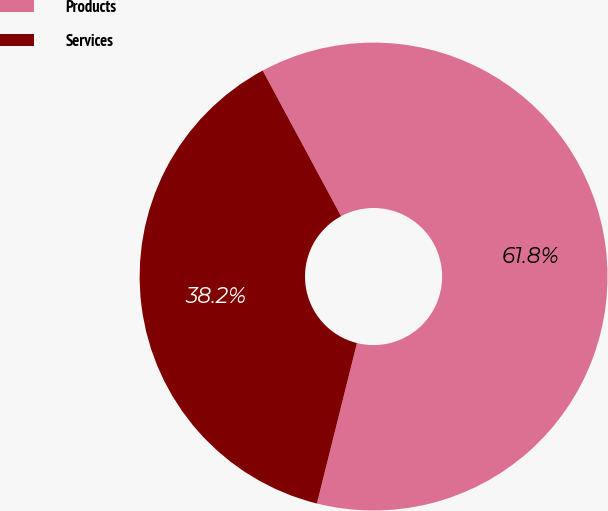Convert chart to OTSL. <chart><loc_0><loc_0><loc_500><loc_500><pie_chart><fcel>Products<fcel>Services<nl><fcel>61.75%<fcel>38.25%<nl></chart> 